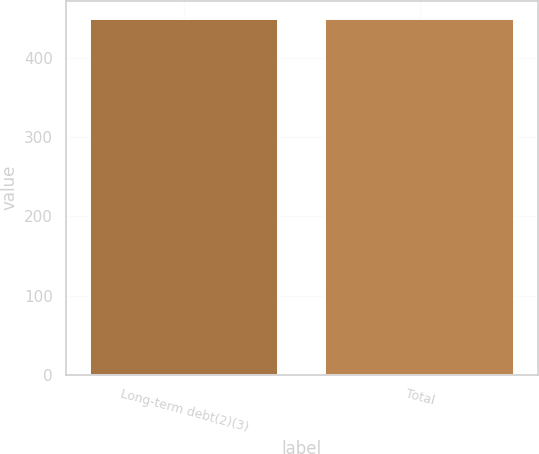Convert chart to OTSL. <chart><loc_0><loc_0><loc_500><loc_500><bar_chart><fcel>Long-term debt(2)(3)<fcel>Total<nl><fcel>450<fcel>450.1<nl></chart> 